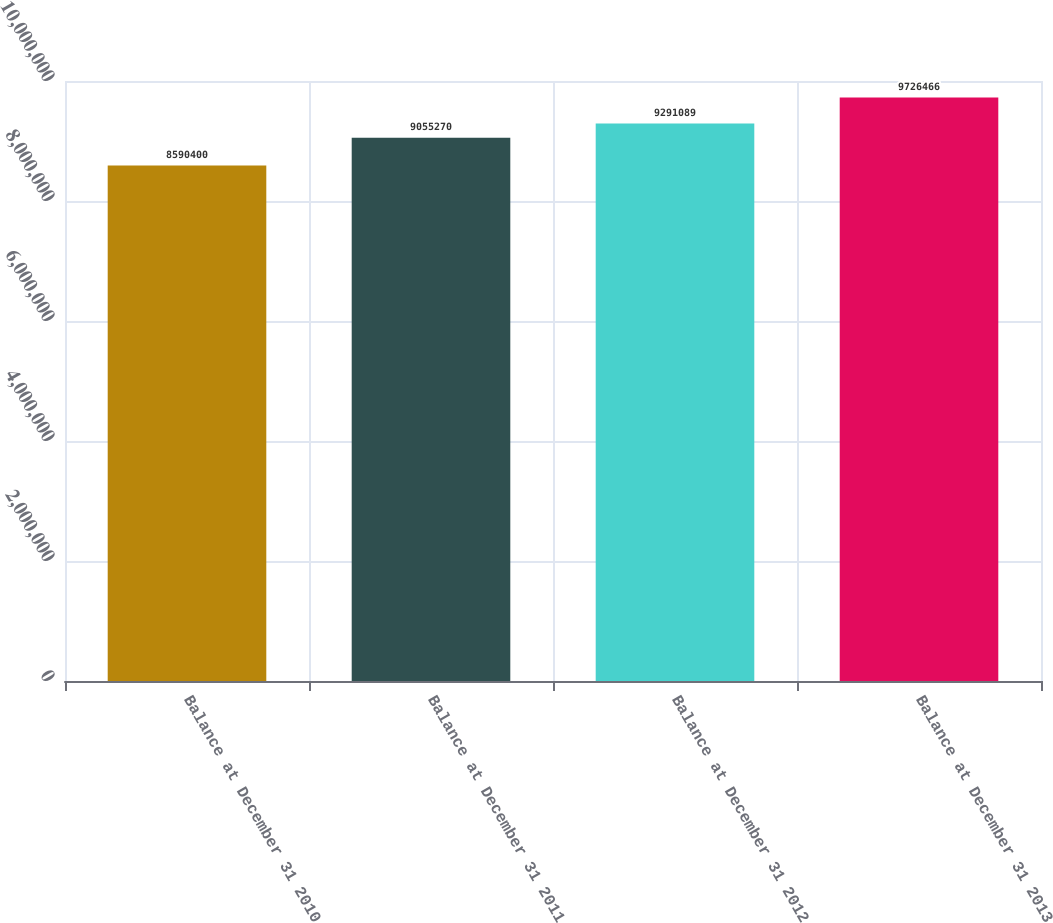<chart> <loc_0><loc_0><loc_500><loc_500><bar_chart><fcel>Balance at December 31 2010<fcel>Balance at December 31 2011<fcel>Balance at December 31 2012<fcel>Balance at December 31 2013<nl><fcel>8.5904e+06<fcel>9.05527e+06<fcel>9.29109e+06<fcel>9.72647e+06<nl></chart> 